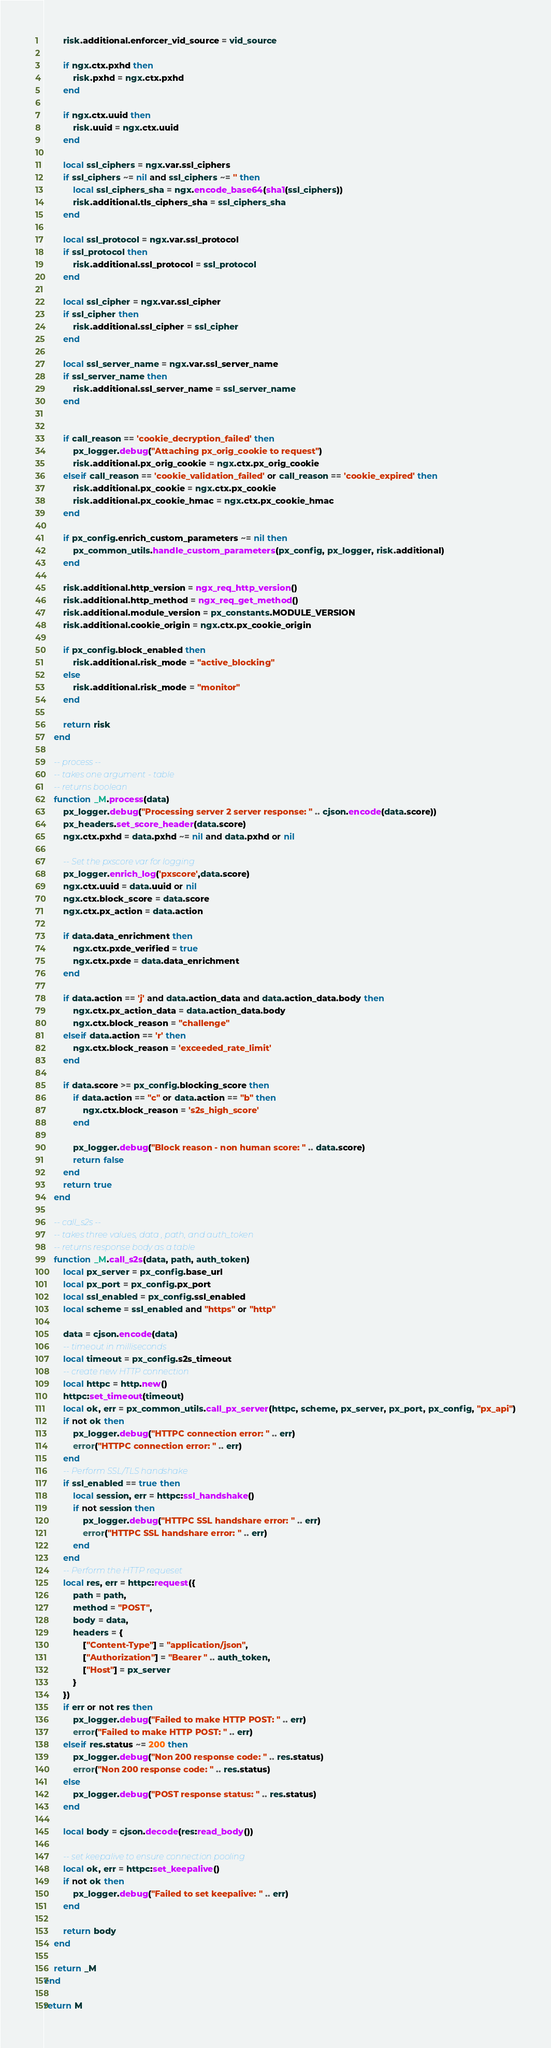<code> <loc_0><loc_0><loc_500><loc_500><_Lua_>
        risk.additional.enforcer_vid_source = vid_source

        if ngx.ctx.pxhd then
            risk.pxhd = ngx.ctx.pxhd
        end

        if ngx.ctx.uuid then
            risk.uuid = ngx.ctx.uuid
        end

        local ssl_ciphers = ngx.var.ssl_ciphers
        if ssl_ciphers ~= nil and ssl_ciphers ~= '' then
            local ssl_ciphers_sha = ngx.encode_base64(sha1(ssl_ciphers))
            risk.additional.tls_ciphers_sha = ssl_ciphers_sha
        end

        local ssl_protocol = ngx.var.ssl_protocol
        if ssl_protocol then
            risk.additional.ssl_protocol = ssl_protocol
        end

        local ssl_cipher = ngx.var.ssl_cipher
        if ssl_cipher then
            risk.additional.ssl_cipher = ssl_cipher
        end

        local ssl_server_name = ngx.var.ssl_server_name
        if ssl_server_name then
            risk.additional.ssl_server_name = ssl_server_name
        end


        if call_reason == 'cookie_decryption_failed' then
            px_logger.debug("Attaching px_orig_cookie to request")
            risk.additional.px_orig_cookie = ngx.ctx.px_orig_cookie
        elseif call_reason == 'cookie_validation_failed' or call_reason == 'cookie_expired' then
            risk.additional.px_cookie = ngx.ctx.px_cookie
            risk.additional.px_cookie_hmac = ngx.ctx.px_cookie_hmac
        end

        if px_config.enrich_custom_parameters ~= nil then
            px_common_utils.handle_custom_parameters(px_config, px_logger, risk.additional)
        end

        risk.additional.http_version = ngx_req_http_version()
        risk.additional.http_method = ngx_req_get_method()
        risk.additional.module_version = px_constants.MODULE_VERSION
        risk.additional.cookie_origin = ngx.ctx.px_cookie_origin

        if px_config.block_enabled then
            risk.additional.risk_mode = "active_blocking"
        else
            risk.additional.risk_mode = "monitor"
        end

        return risk
    end

    -- process --
    -- takes one argument - table
    -- returns boolean
    function _M.process(data)
        px_logger.debug("Processing server 2 server response: " .. cjson.encode(data.score))
        px_headers.set_score_header(data.score)
        ngx.ctx.pxhd = data.pxhd ~= nil and data.pxhd or nil

        -- Set the pxscore var for logging
        px_logger.enrich_log('pxscore',data.score)
        ngx.ctx.uuid = data.uuid or nil
        ngx.ctx.block_score = data.score
        ngx.ctx.px_action = data.action

        if data.data_enrichment then
            ngx.ctx.pxde_verified = true
            ngx.ctx.pxde = data.data_enrichment
        end

        if data.action == 'j' and data.action_data and data.action_data.body then
            ngx.ctx.px_action_data = data.action_data.body
            ngx.ctx.block_reason = "challenge"
        elseif data.action == 'r' then
            ngx.ctx.block_reason = 'exceeded_rate_limit'
        end

        if data.score >= px_config.blocking_score then
            if data.action == "c" or data.action == "b" then
                ngx.ctx.block_reason = 's2s_high_score'
            end

            px_logger.debug("Block reason - non human score: " .. data.score)
            return false
        end
        return true
    end

    -- call_s2s --
    -- takes three values, data , path, and auth_token
    -- returns response body as a table
    function _M.call_s2s(data, path, auth_token)
        local px_server = px_config.base_url
        local px_port = px_config.px_port
        local ssl_enabled = px_config.ssl_enabled
        local scheme = ssl_enabled and "https" or "http"

        data = cjson.encode(data)
        -- timeout in milliseconds
        local timeout = px_config.s2s_timeout
        -- create new HTTP connection
        local httpc = http.new()
        httpc:set_timeout(timeout)
        local ok, err = px_common_utils.call_px_server(httpc, scheme, px_server, px_port, px_config, "px_api")
        if not ok then
            px_logger.debug("HTTPC connection error: " .. err)
            error("HTTPC connection error: " .. err)
        end
        -- Perform SSL/TLS handshake
        if ssl_enabled == true then
            local session, err = httpc:ssl_handshake()
            if not session then
                px_logger.debug("HTTPC SSL handshare error: " .. err)
                error("HTTPC SSL handshare error: " .. err)
            end
        end
        -- Perform the HTTP requeset
        local res, err = httpc:request({
            path = path,
            method = "POST",
            body = data,
            headers = {
                ["Content-Type"] = "application/json",
                ["Authorization"] = "Bearer " .. auth_token,
                ["Host"] = px_server
            }
        })
        if err or not res then
            px_logger.debug("Failed to make HTTP POST: " .. err)
            error("Failed to make HTTP POST: " .. err)
        elseif res.status ~= 200 then
            px_logger.debug("Non 200 response code: " .. res.status)
            error("Non 200 response code: " .. res.status)
        else
            px_logger.debug("POST response status: " .. res.status)
        end

        local body = cjson.decode(res:read_body())

        -- set keepalive to ensure connection pooling
        local ok, err = httpc:set_keepalive()
        if not ok then
            px_logger.debug("Failed to set keepalive: " .. err)
        end

        return body
    end

    return _M
end

return M
</code> 